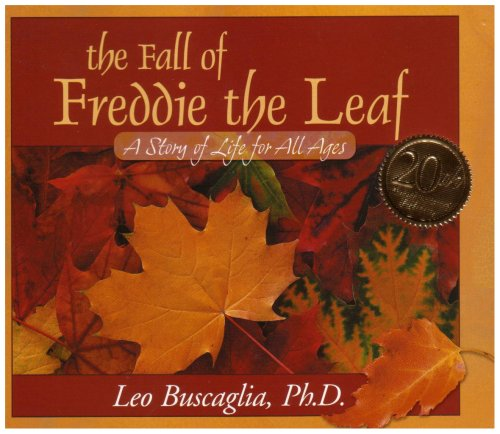Why is this book suitable for all ages? Though it appears to be a simple story about a leaf, 'The Fall of Freddie the Leaf' tackles profound subjects like life and mortality in a tender, accessible manner, making it a valuable read for both children and adults to appreciate at any stage of life. 